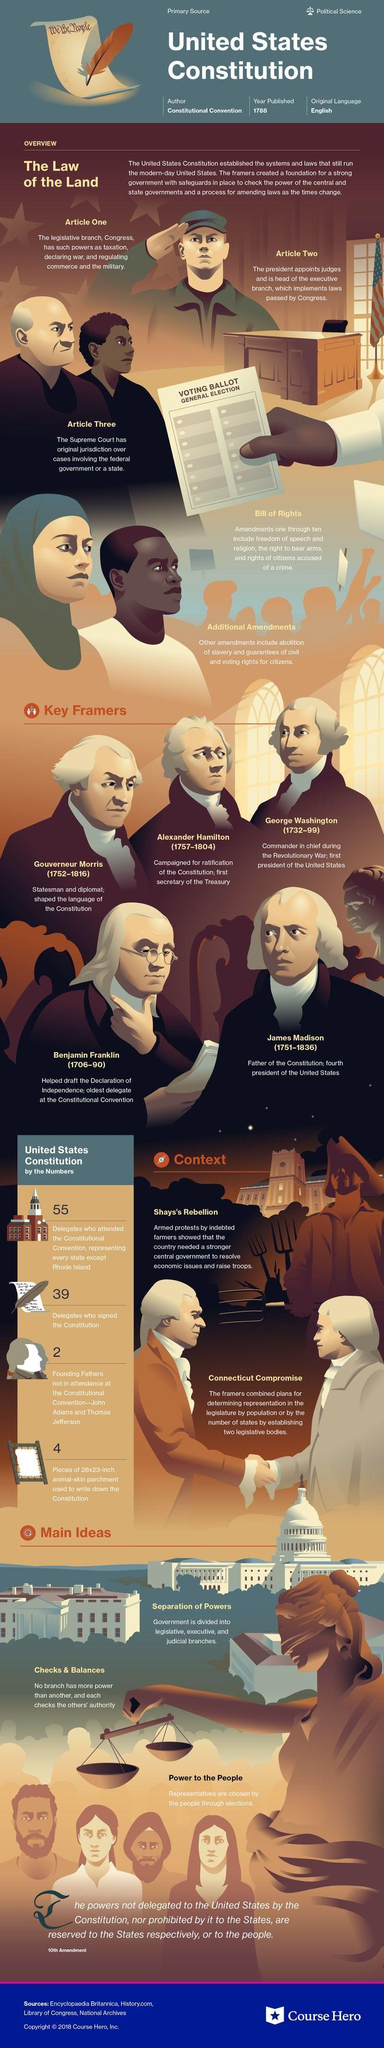Give some essential details in this illustration. The Bill of Rights contains ten amendments. James Madison is widely recognized as the Father of the Constitution. The legislative branch is responsible for regulating the military. The material used to write the Constitution was 28 inches wide and 23 inches tall. There are three articles mentioned in this text. 